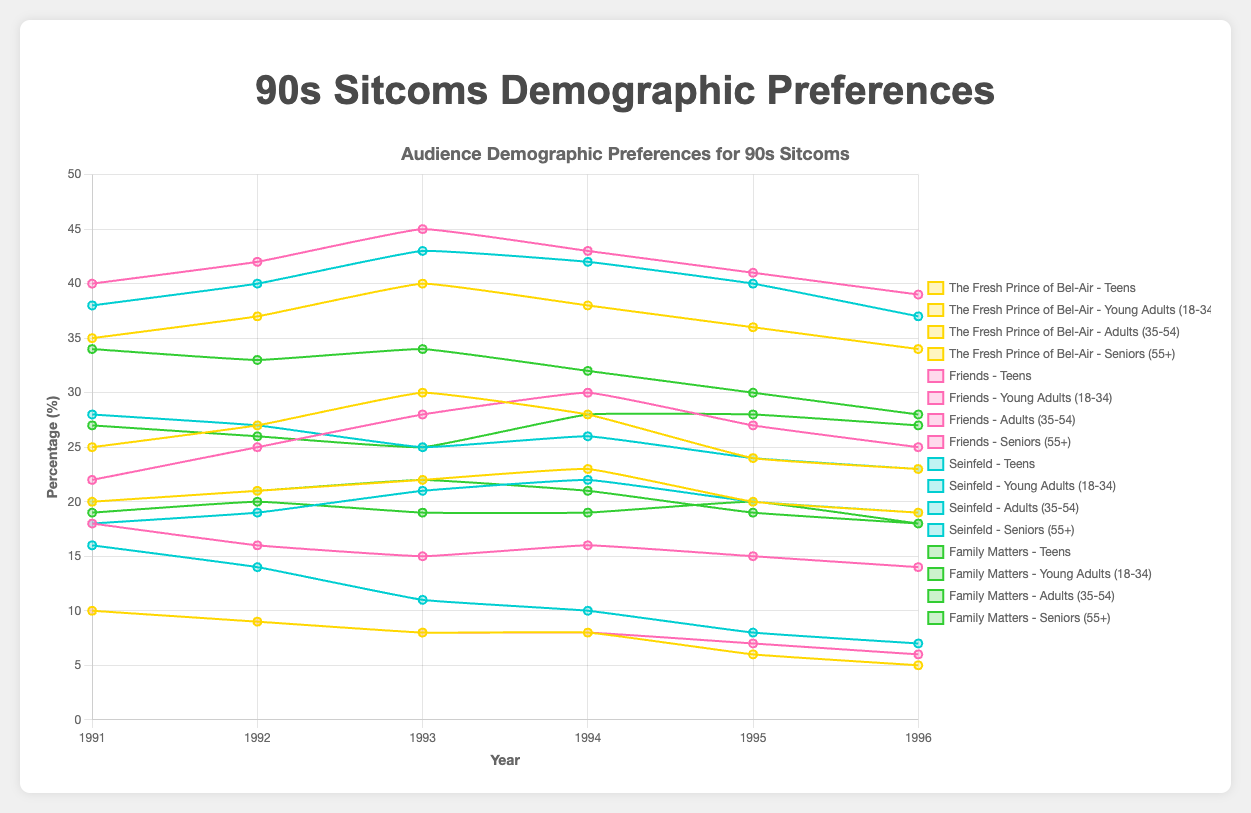What was the trend in teen viewership for 'The Fresh Prince of Bel-Air' from 1991 to 1996? The teen viewership for 'The Fresh Prince of Bel-Air' started at 25% in 1991, increased to 30% in 1993, and then gradually decreased to 23% by 1996.
Answer: Increasing from 1991 to 1993, then decreasing till 1996 Which show had the highest percentage of young adult viewers (18-34) in 1994? In 1994, 'Friends' had the highest percentage of young adult viewers with 43%, compared to 'The Fresh Prince of Bel-Air' with 38%, 'Seinfeld' with 42%, and 'Family Matters' with 32%.
Answer: Friends How did the percentage of adult viewers (35-54) for 'Seinfeld' change from 1991 to 1996? The adult viewership for 'Seinfeld' decreased from 28% in 1991 to 23% in 1996, showing a general downward trend over the years.
Answer: Decreasing Compare the percentage of senior viewers (55+) for 'The Fresh Prince of Bel-Air' and 'Friends' in 1993. Which was higher, and by how much? In 1993, 'The Fresh Prince of Bel-Air' had 8% senior viewers and 'Friends' also had 8% senior viewers, hence both shows had the same percentage of senior viewers in 1993.
Answer: Equal Among the 'Teens' demographic, which show saw the most fluctuating percentage change from 1991 to 1996? 'The Fresh Prince of Bel-Air' had the most fluctuations among teens viewers, starting at 25% in 1991, rising to 30% in 1993, then falling to 23% by 1996, which shows the greatest variation.
Answer: The Fresh Prince of Bel-Air Which demographic group had the most consistent percentage in 'Family Matters' from 1991 to 1996? The adult (35-54) demographic in 'Family Matters' was the most consistent, varying between 25% and 28% from 1991 to 1996.
Answer: Adults (35-54) What was the total percentage change of young adult viewers (18-34) for 'Friends' from 1991 to 1996? In 1991, 'Friends' had 40% young adult viewers and 39% in 1996. The total percentage change is 39 - 40 = -1%.
Answer: -1% Which show had the most diverse audience in terms of the spread across demographics in 1995? In 1995, 'Family Matters' had a relatively balanced distribution with Teens (19%), Young Adults (30%), Adults (28%), and Seniors (20%).
Answer: Family Matters What was the average percentage of seniors (55+) who watched 'Seinfeld' from 1991 to 1996? The percentages for seniors watching 'Seinfeld' from 1991 to 1996 are 16, 14, 11, 10, 8, and 7. Adding these gives a total of 66. Dividing by 6 years, the average is 66/6 = 11%.
Answer: 11% 